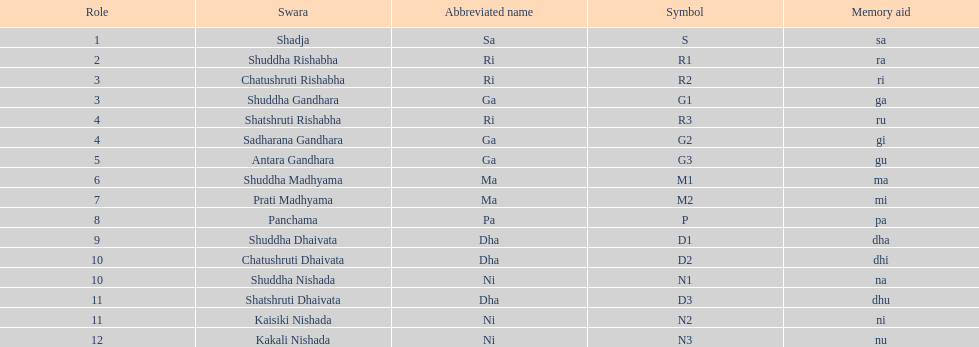Which swara follows immediately after antara gandhara? Shuddha Madhyama. 